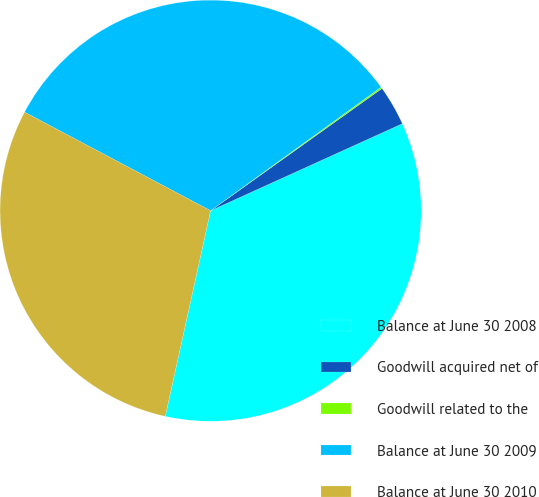<chart> <loc_0><loc_0><loc_500><loc_500><pie_chart><fcel>Balance at June 30 2008<fcel>Goodwill acquired net of<fcel>Goodwill related to the<fcel>Balance at June 30 2009<fcel>Balance at June 30 2010<nl><fcel>35.23%<fcel>3.08%<fcel>0.12%<fcel>32.26%<fcel>29.3%<nl></chart> 